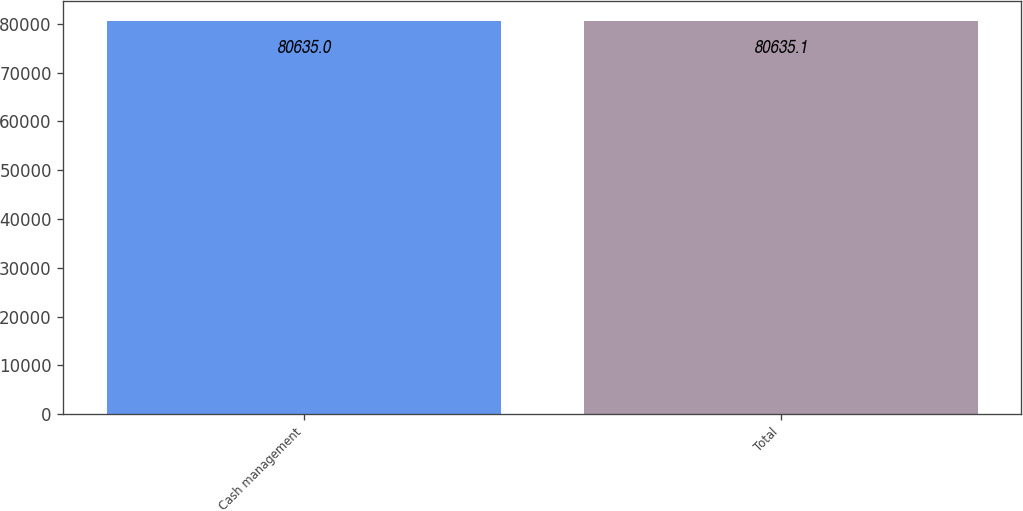Convert chart to OTSL. <chart><loc_0><loc_0><loc_500><loc_500><bar_chart><fcel>Cash management<fcel>Total<nl><fcel>80635<fcel>80635.1<nl></chart> 